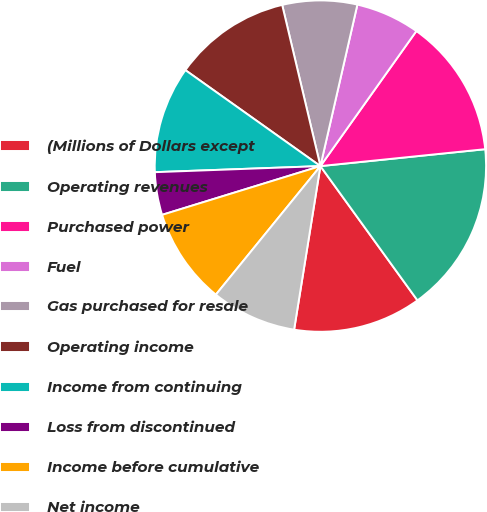Convert chart. <chart><loc_0><loc_0><loc_500><loc_500><pie_chart><fcel>(Millions of Dollars except<fcel>Operating revenues<fcel>Purchased power<fcel>Fuel<fcel>Gas purchased for resale<fcel>Operating income<fcel>Income from continuing<fcel>Loss from discontinued<fcel>Income before cumulative<fcel>Net income<nl><fcel>12.5%<fcel>16.67%<fcel>13.54%<fcel>6.25%<fcel>7.29%<fcel>11.46%<fcel>10.42%<fcel>4.17%<fcel>9.38%<fcel>8.33%<nl></chart> 